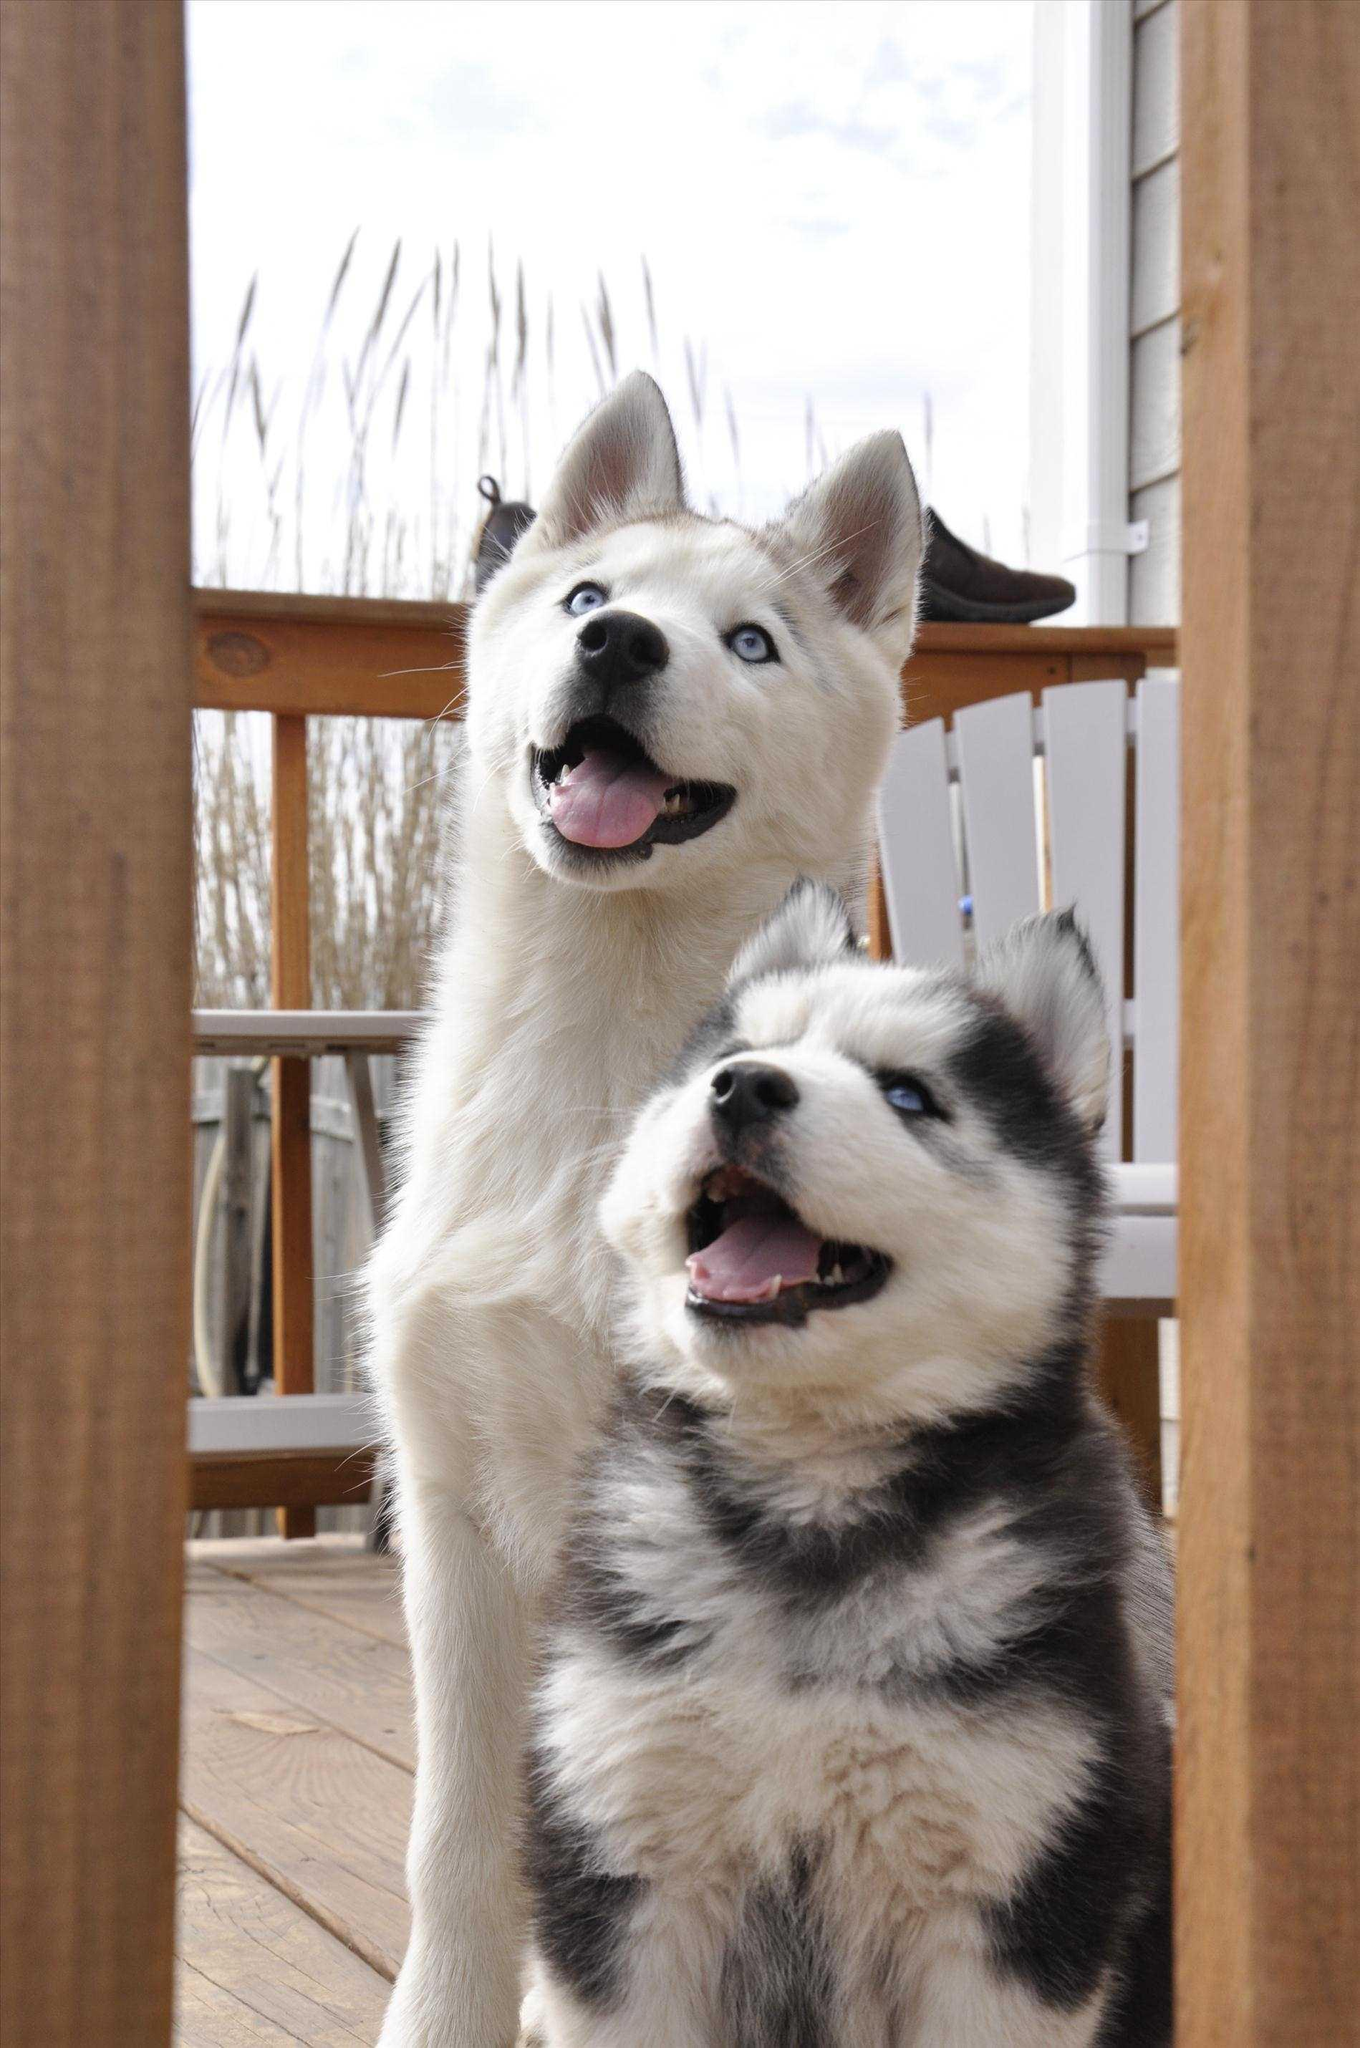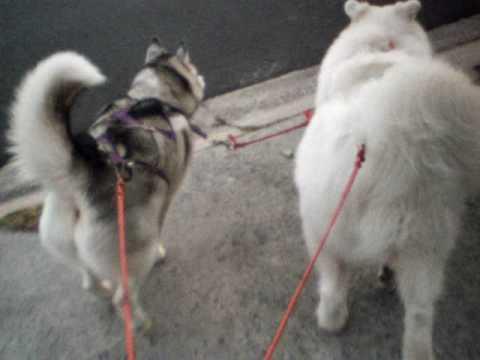The first image is the image on the left, the second image is the image on the right. Considering the images on both sides, is "A person wearing jeans is next to multiple dogs in one image." valid? Answer yes or no. No. The first image is the image on the left, the second image is the image on the right. Assess this claim about the two images: "In one of the images there is a small black dog on top of a big white dog that is laying on the floor.". Correct or not? Answer yes or no. No. 